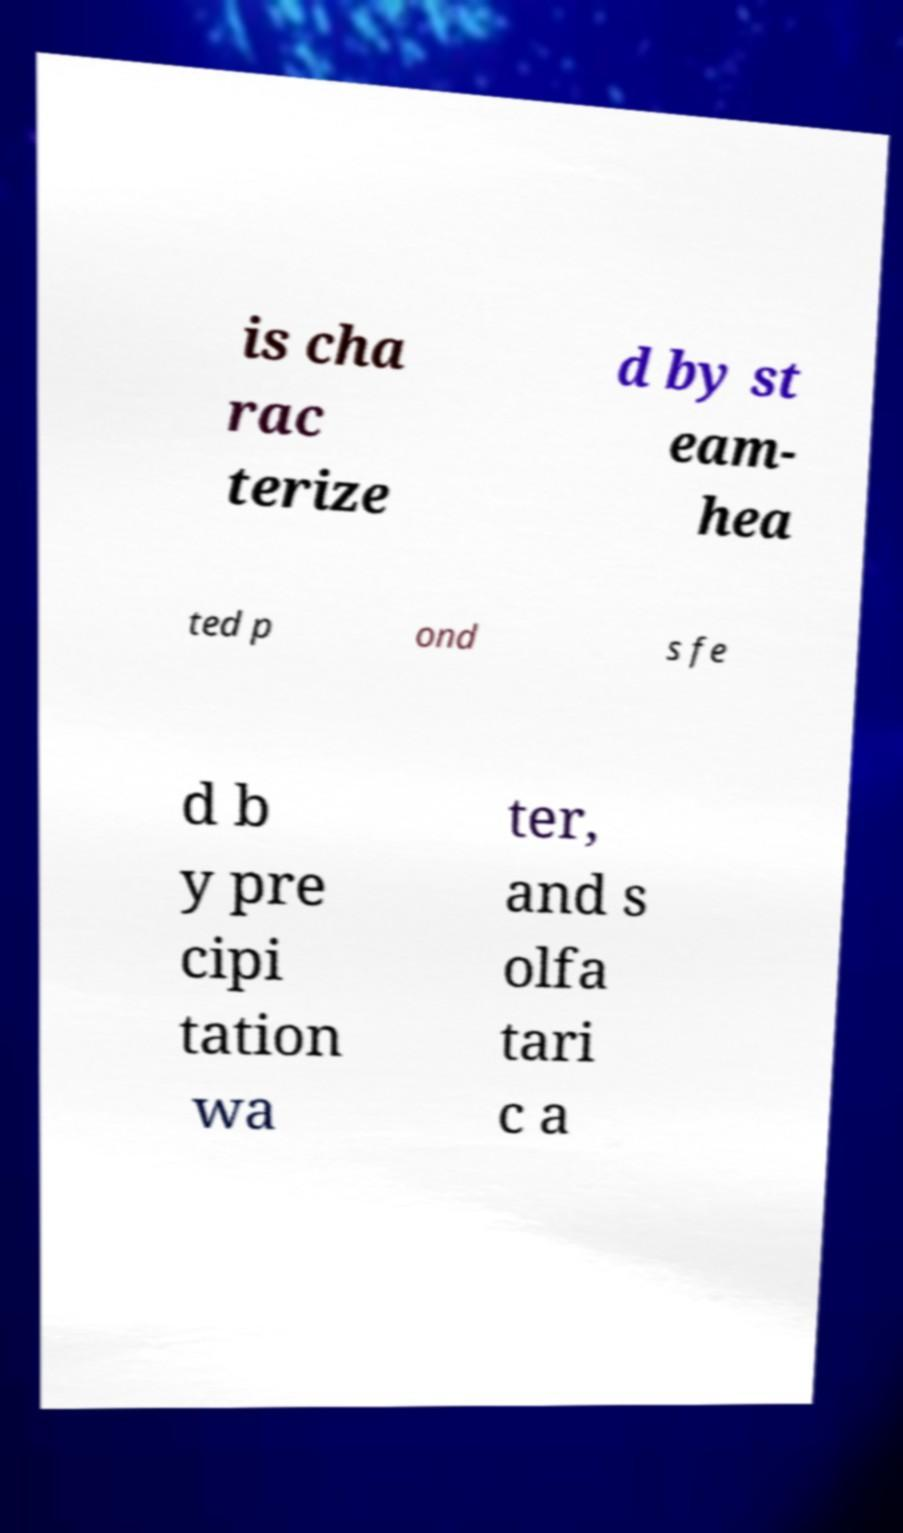Can you read and provide the text displayed in the image?This photo seems to have some interesting text. Can you extract and type it out for me? is cha rac terize d by st eam- hea ted p ond s fe d b y pre cipi tation wa ter, and s olfa tari c a 